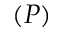<formula> <loc_0><loc_0><loc_500><loc_500>( P )</formula> 